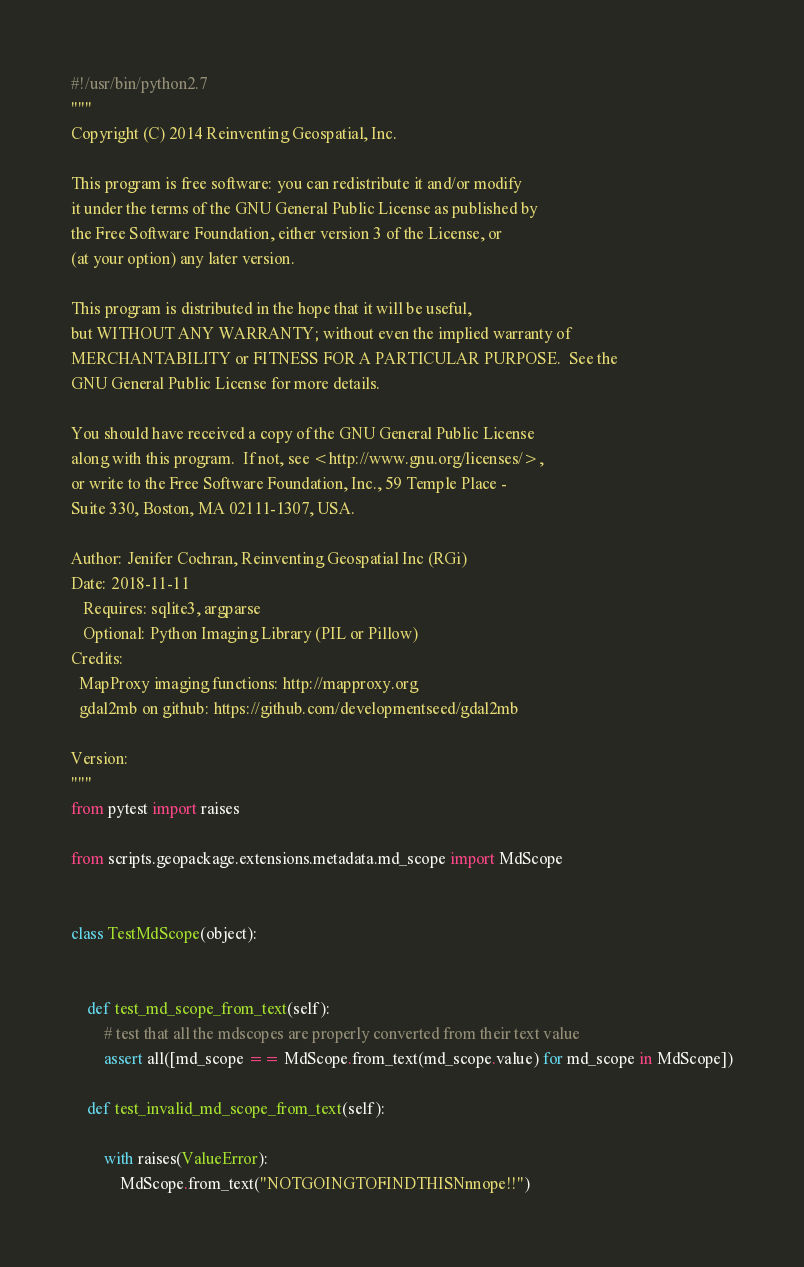Convert code to text. <code><loc_0><loc_0><loc_500><loc_500><_Python_>#!/usr/bin/python2.7
"""
Copyright (C) 2014 Reinventing Geospatial, Inc.

This program is free software: you can redistribute it and/or modify
it under the terms of the GNU General Public License as published by
the Free Software Foundation, either version 3 of the License, or
(at your option) any later version.

This program is distributed in the hope that it will be useful,
but WITHOUT ANY WARRANTY; without even the implied warranty of
MERCHANTABILITY or FITNESS FOR A PARTICULAR PURPOSE.  See the
GNU General Public License for more details.

You should have received a copy of the GNU General Public License
along with this program.  If not, see <http://www.gnu.org/licenses/>,
or write to the Free Software Foundation, Inc., 59 Temple Place -
Suite 330, Boston, MA 02111-1307, USA.

Author: Jenifer Cochran, Reinventing Geospatial Inc (RGi)
Date: 2018-11-11
   Requires: sqlite3, argparse
   Optional: Python Imaging Library (PIL or Pillow)
Credits:
  MapProxy imaging functions: http://mapproxy.org
  gdal2mb on github: https://github.com/developmentseed/gdal2mb

Version:
"""
from pytest import raises

from scripts.geopackage.extensions.metadata.md_scope import MdScope


class TestMdScope(object):


    def test_md_scope_from_text(self):
        # test that all the mdscopes are properly converted from their text value
        assert all([md_scope == MdScope.from_text(md_scope.value) for md_scope in MdScope])

    def test_invalid_md_scope_from_text(self):

        with raises(ValueError):
            MdScope.from_text("NOTGOINGTOFINDTHISNnnope!!")</code> 